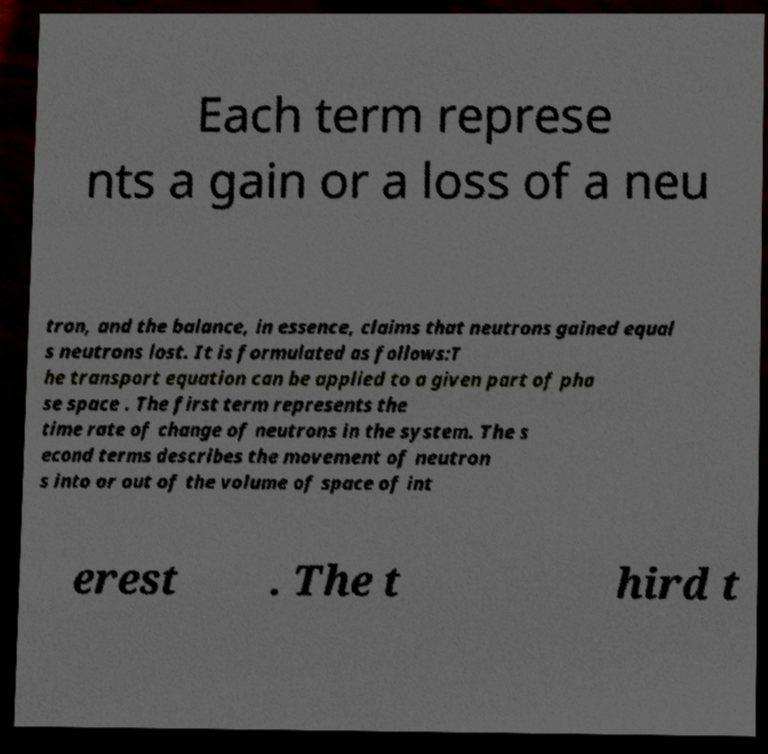What messages or text are displayed in this image? I need them in a readable, typed format. Each term represe nts a gain or a loss of a neu tron, and the balance, in essence, claims that neutrons gained equal s neutrons lost. It is formulated as follows:T he transport equation can be applied to a given part of pha se space . The first term represents the time rate of change of neutrons in the system. The s econd terms describes the movement of neutron s into or out of the volume of space of int erest . The t hird t 